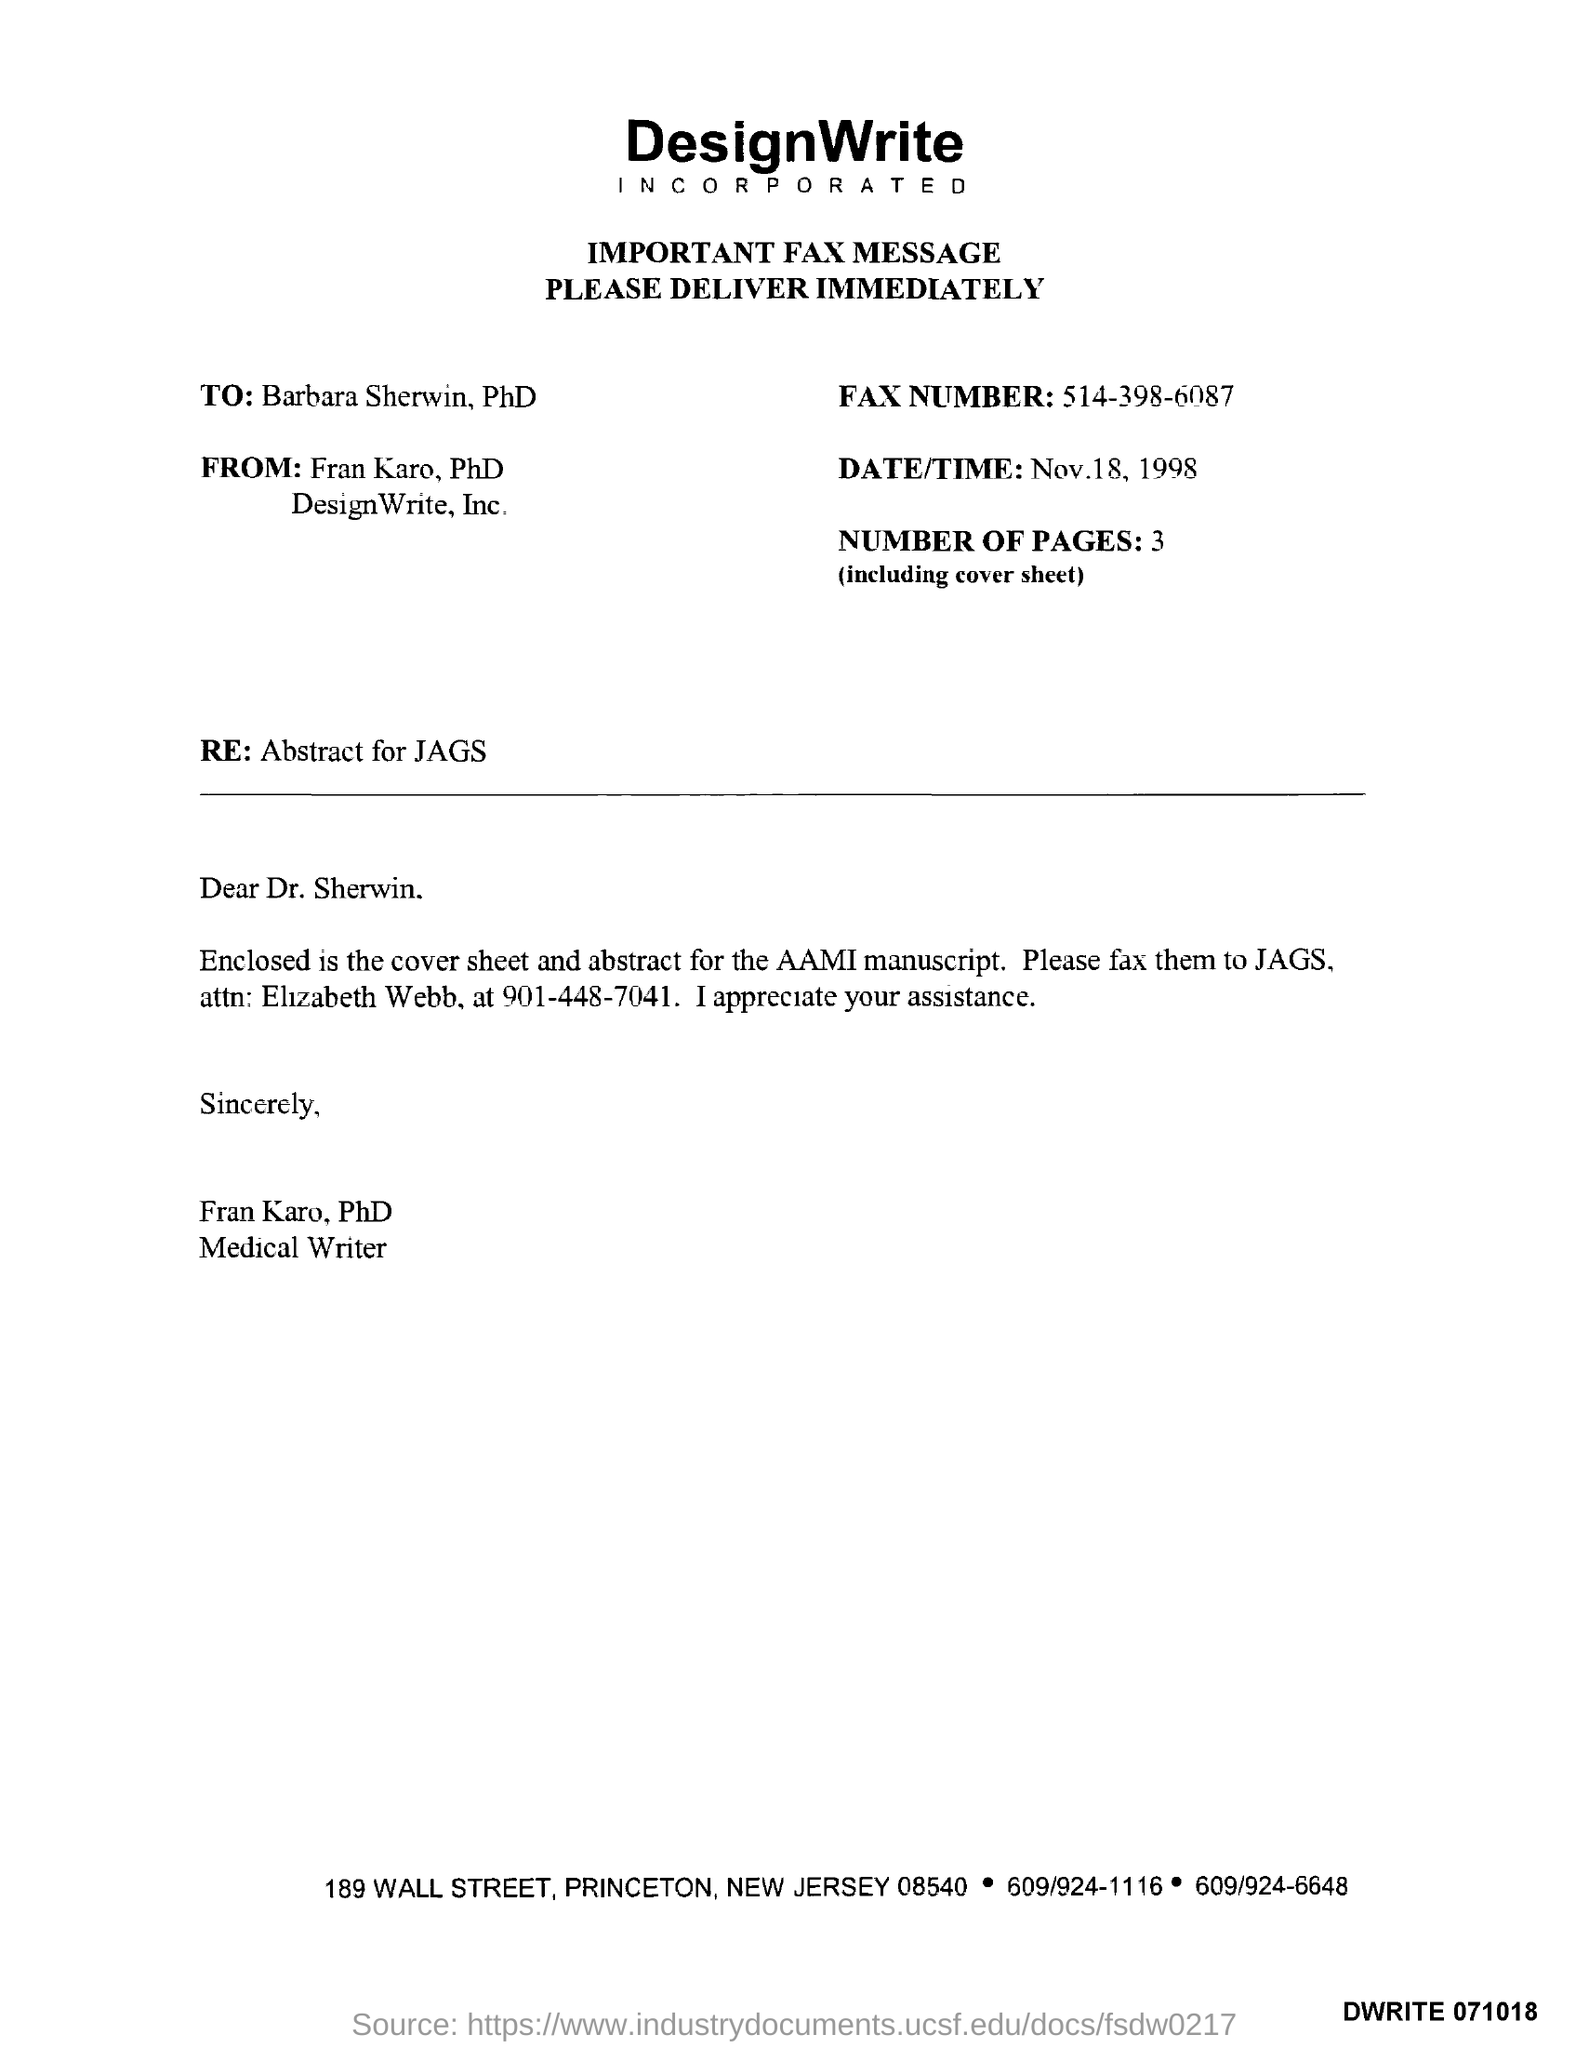Point out several critical features in this image. The message that is written immediately below the heading "Important Fax Message" should be delivered immediately. 